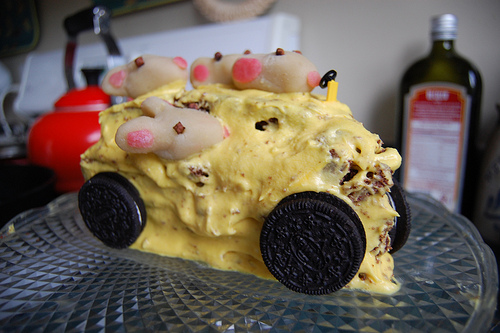<image>
Is there a mouse behind the cookie? No. The mouse is not behind the cookie. From this viewpoint, the mouse appears to be positioned elsewhere in the scene. 